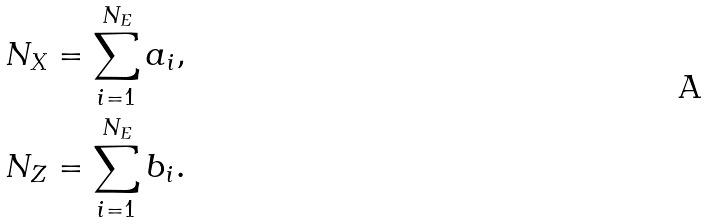Convert formula to latex. <formula><loc_0><loc_0><loc_500><loc_500>\\ N _ { X } & = \sum _ { i = 1 } ^ { N _ { E } } a _ { i } , \\ N _ { Z } & = \sum _ { i = 1 } ^ { N _ { E } } b _ { i } .</formula> 